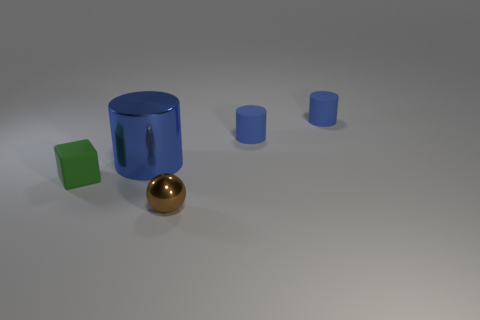Add 3 brown metal things. How many objects exist? 8 Subtract all cylinders. How many objects are left? 2 Add 5 small rubber cylinders. How many small rubber cylinders are left? 7 Add 4 tiny red spheres. How many tiny red spheres exist? 4 Subtract 0 gray spheres. How many objects are left? 5 Subtract all cyan metal cubes. Subtract all brown metal objects. How many objects are left? 4 